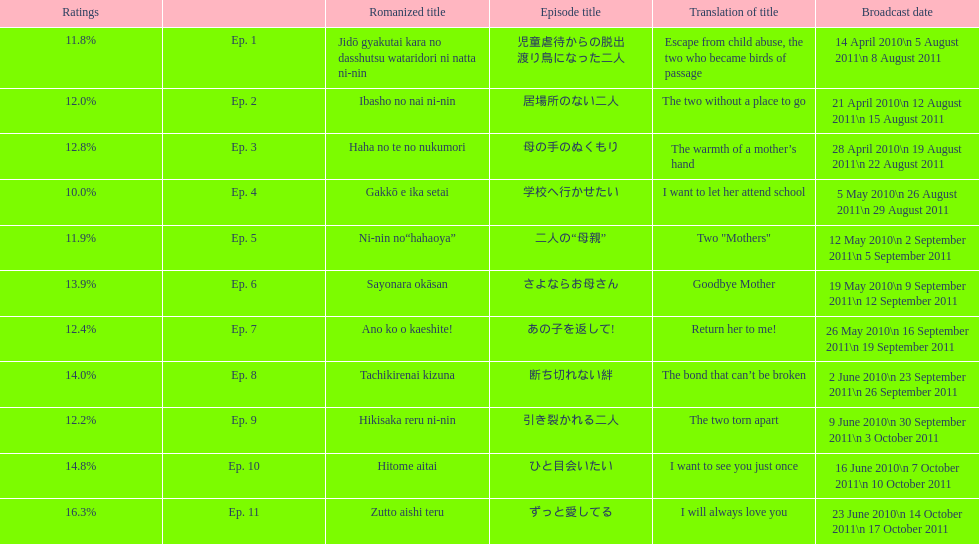What was the name of the next episode after goodbye mother? あの子を返して!. 